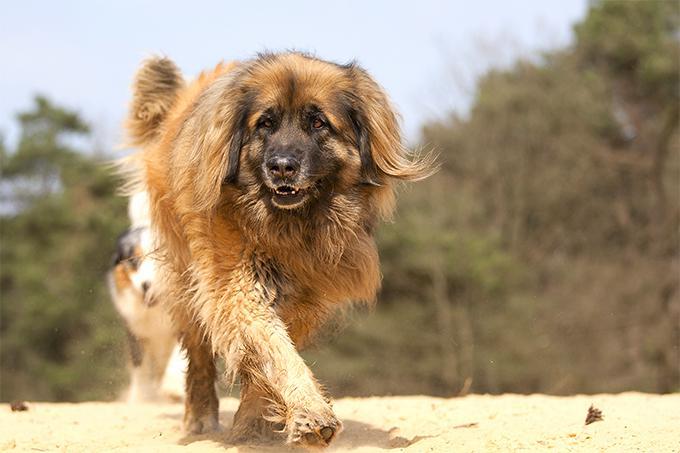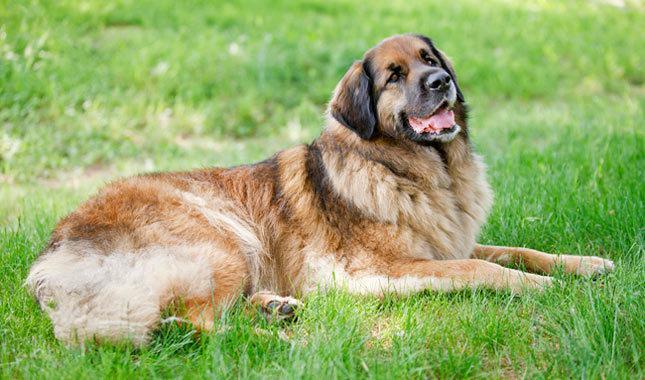The first image is the image on the left, the second image is the image on the right. For the images displayed, is the sentence "The dog in the image on the right is standing in full profile facing the right." factually correct? Answer yes or no. No. 